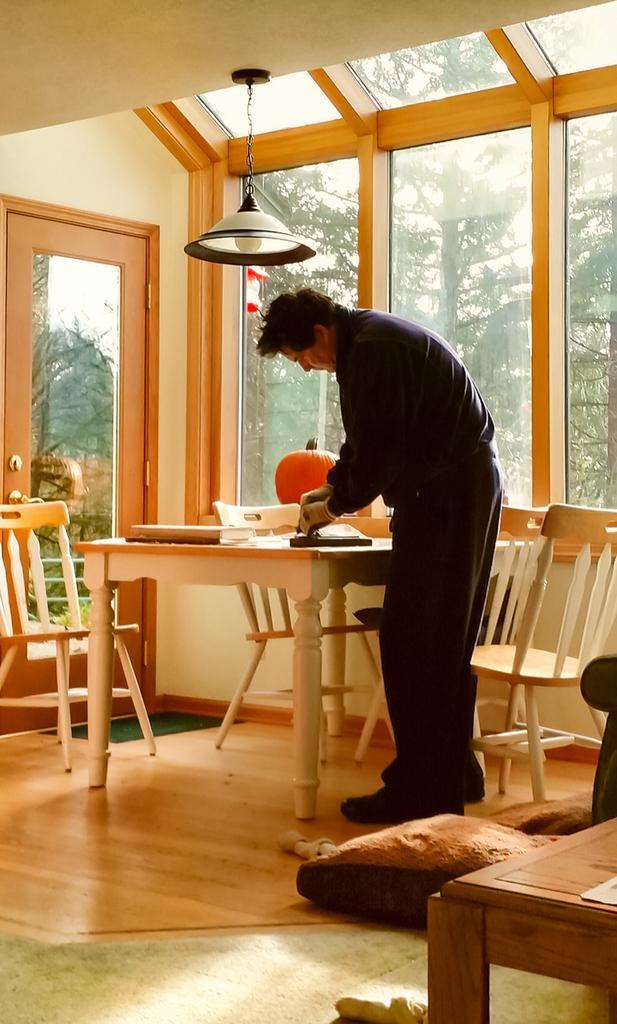How would you summarize this image in a sentence or two? In the middle of the image a man is standing and holding something in his hands. Bottom right side of the image there is a chair. In the middle of the image there is a table on the table there are some products and there is a book. Surrounding the table there are some chairs. Top left side of the image there is a wall and door. Top right side of the image there is a glass window through the glass window we can see some trees. In the middle of the image there is a light. 